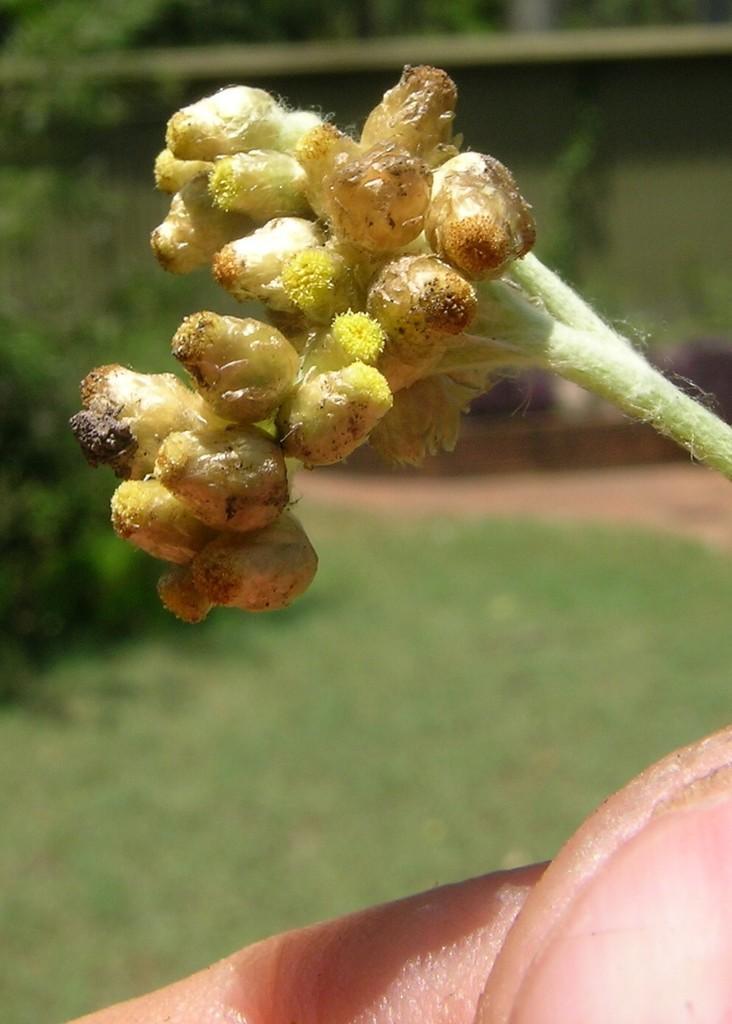Could you give a brief overview of what you see in this image? In this picture we can see a flower bud holding in his hand and in the background we can see grass, path, trees and it is blurry. 